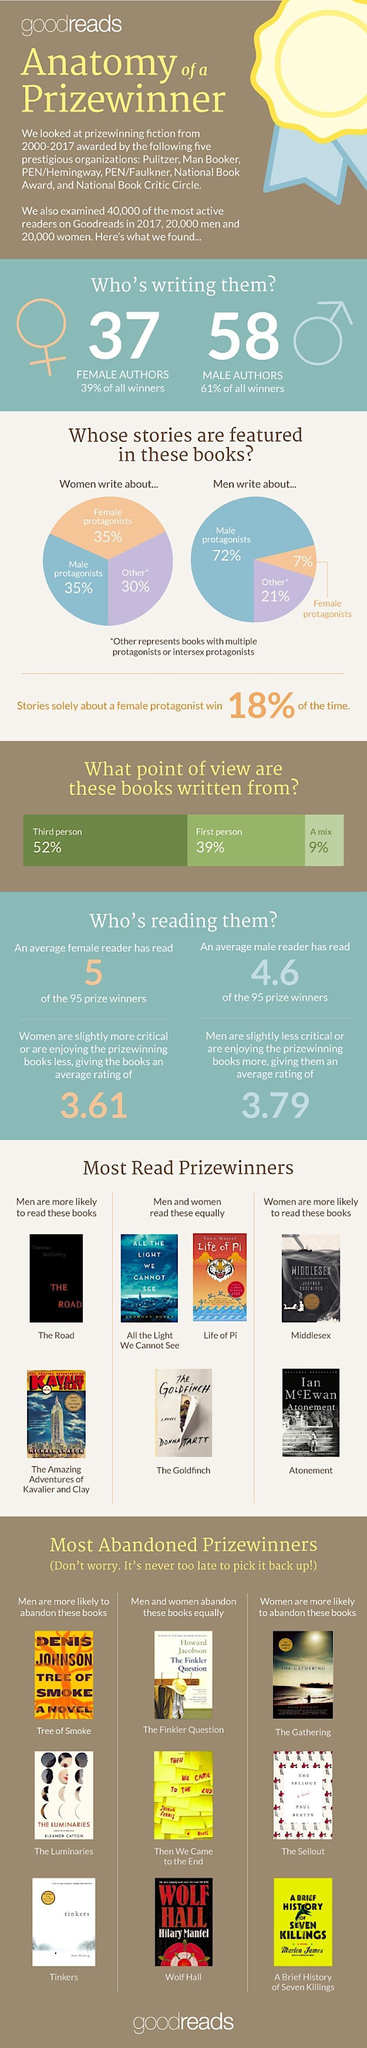Which books are more likely to be read by males
Answer the question with a short phrase. The Road, The Amazing Adventures of Kavalier and Clay What is the share of male and female protagonists each when written by women 35% What % of books are written from the point of the first person 39% Which books are more likely to be read by females Middlesex, Atonement What % of the most active readers in Goodreads are male 50 Which books are more likely to be abandoned by males Tinkers, The Luminaries, Tree of Smoke Which books have been read by both male and female equally All the light we cannot see, Life of Pi, The Goldfinch What is the share of female protagonish topics when the book is written by males 7% Which books are more likely to be abandoned by females The Gathering, The Sellout, A brief History of Seven Killings 